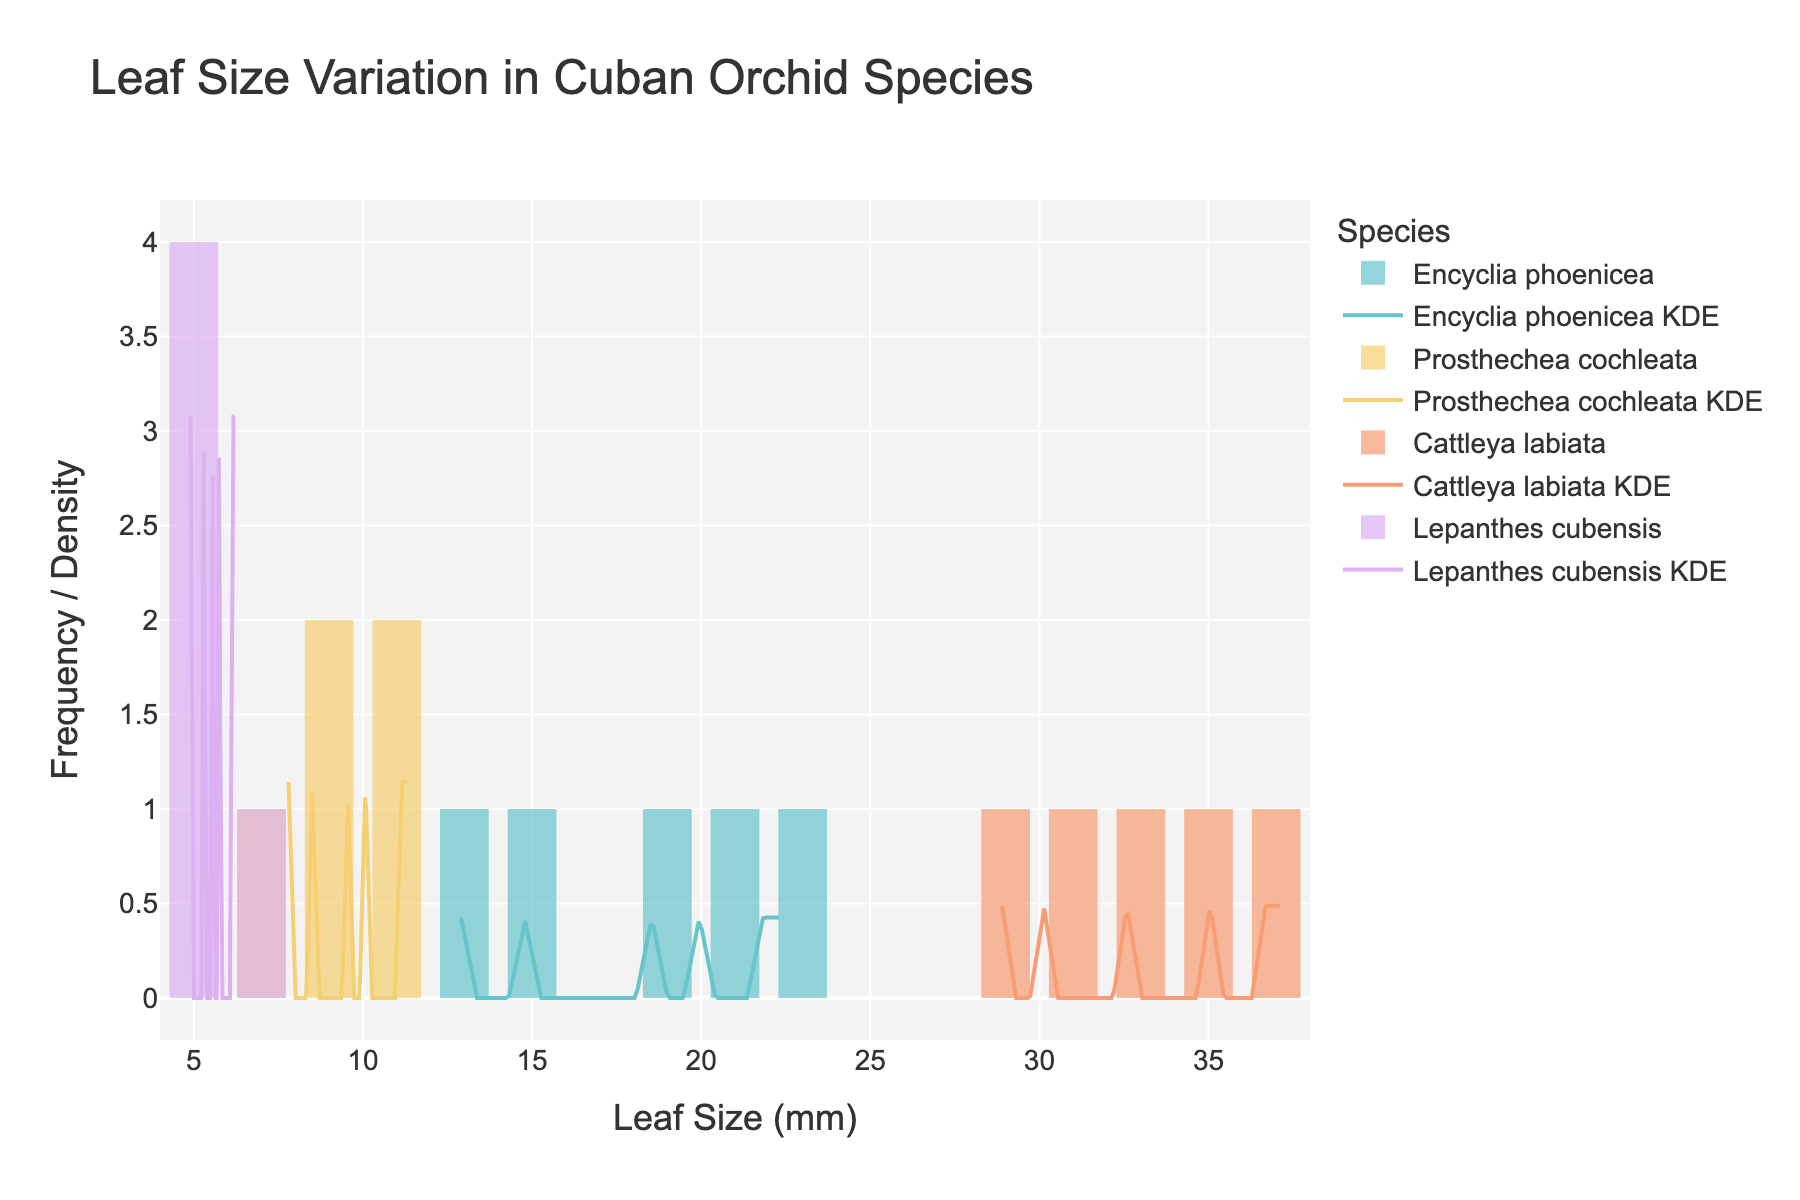what is the title of the figure? The title is typically displayed at the top of the figure. It summarizes the main subject of the visual representation.
Answer: Leaf Size Variation in Cuban Orchid Species what is the range of leaf sizes for Cattleya labiata? To determine the range, look at the x-axis and the histogram bins for Cattleya labiata. Identify the minimum and maximum leaf sizes within those bins.
Answer: 28.9 to 37.1 mm which species has the most frequency in the smallest leaf size range? Look at the bars on the leftmost side of the x-axis and identify the species with the highest bar in that range.
Answer: Lepanthes cubensis which species' KDE curve peaks at the highest density value? Examine the peak (highest point) of each KDE curve. Identify which curve has the highest peak.
Answer: Lepanthes cubensis how does the leaf size variation in Prosthechea cochleata compare to Encyclia phoenicea? Compare the spread and heights of the histograms and KDE curves of both species. Notice differences in the spread, density, and concentration of values.
Answer: Prosthechea cochleata shows smaller and less varied leaf sizes compared to Encyclia phoenicea, which has larger and more varied sizes what is the approximate median leaf size for Encyclia phoenicea? The median is the value separating the higher half from the lower half. Locate the middle value within the histogram bins or KDE curve for Encyclia phoenicea.
Answer: Around 18.7 mm which species has the widest range of leaf sizes? Look at the spread of each species' histogram and note the range from the smallest to the largest value. Identify which species has the largest difference.
Answer: Cattleya labiata compare the leaf size distribution of Lepanthes cubensis to Cattleya labiata. Cattleya labiata have larger leaves spanning from around 28.9 to 37.1 mm, with a wider and more spread-out distribution. Lepanthes cubensis have smaller leaves, mainly around 4.9 to 6.2 mm, with a narrower, more concentrated distribution.
Answer: Cattleya labiata has broader and larger leaf sizes compared to Lepanthes cubensis what is the mode leaf size range for Prosthechea cochleata? The mode is the leaf size range that appears most frequently. Check the highest bar in the histogram for Prosthechea cochleata to determine the range.
Answer: 9-11 mm 